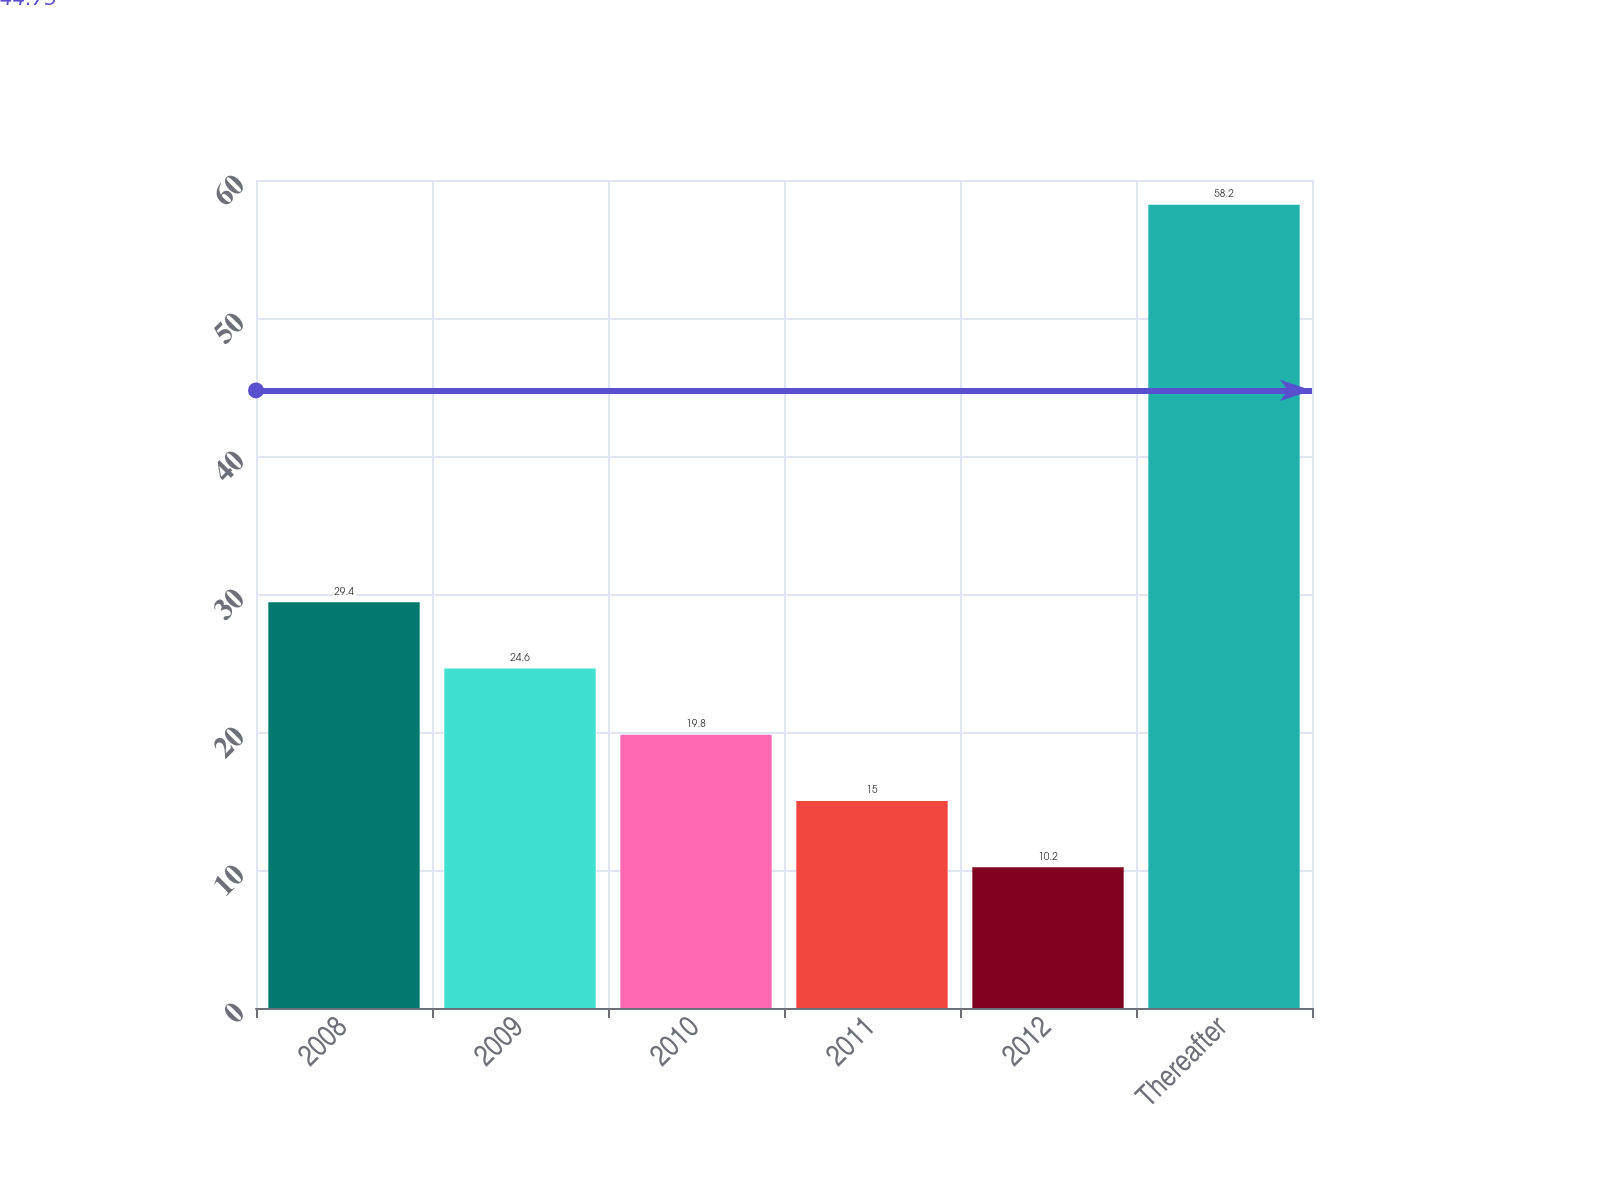Convert chart. <chart><loc_0><loc_0><loc_500><loc_500><bar_chart><fcel>2008<fcel>2009<fcel>2010<fcel>2011<fcel>2012<fcel>Thereafter<nl><fcel>29.4<fcel>24.6<fcel>19.8<fcel>15<fcel>10.2<fcel>58.2<nl></chart> 